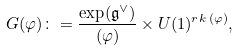<formula> <loc_0><loc_0><loc_500><loc_500>G ( \varphi ) \colon = \frac { \exp ( \mathfrak { g } ^ { \vee } ) } { ( \varphi ) } \times U ( 1 ) ^ { r k \, ( \varphi ) } ,</formula> 